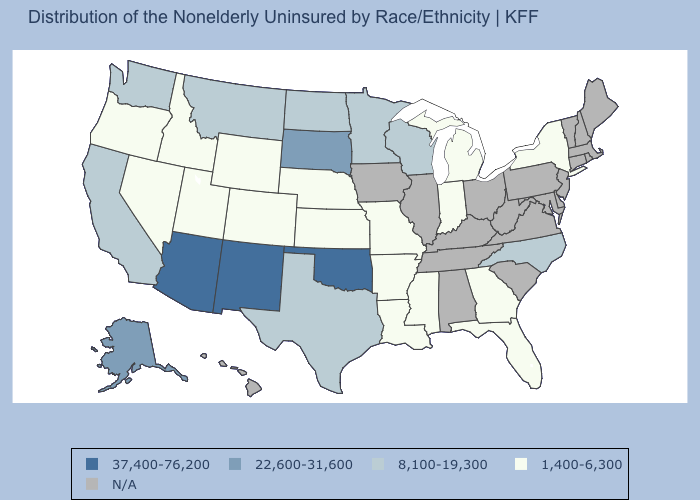What is the value of Alaska?
Concise answer only. 22,600-31,600. What is the highest value in the USA?
Be succinct. 37,400-76,200. How many symbols are there in the legend?
Give a very brief answer. 5. Name the states that have a value in the range 22,600-31,600?
Keep it brief. Alaska, South Dakota. What is the highest value in the USA?
Short answer required. 37,400-76,200. What is the value of North Carolina?
Write a very short answer. 8,100-19,300. Name the states that have a value in the range 1,400-6,300?
Be succinct. Arkansas, Colorado, Florida, Georgia, Idaho, Indiana, Kansas, Louisiana, Michigan, Mississippi, Missouri, Nebraska, Nevada, New York, Oregon, Utah, Wyoming. Name the states that have a value in the range 1,400-6,300?
Give a very brief answer. Arkansas, Colorado, Florida, Georgia, Idaho, Indiana, Kansas, Louisiana, Michigan, Mississippi, Missouri, Nebraska, Nevada, New York, Oregon, Utah, Wyoming. Among the states that border Tennessee , which have the highest value?
Concise answer only. North Carolina. Among the states that border Colorado , which have the lowest value?
Keep it brief. Kansas, Nebraska, Utah, Wyoming. Which states have the highest value in the USA?
Short answer required. Arizona, New Mexico, Oklahoma. Name the states that have a value in the range 22,600-31,600?
Concise answer only. Alaska, South Dakota. What is the lowest value in the MidWest?
Concise answer only. 1,400-6,300. Does Idaho have the highest value in the USA?
Be succinct. No. 